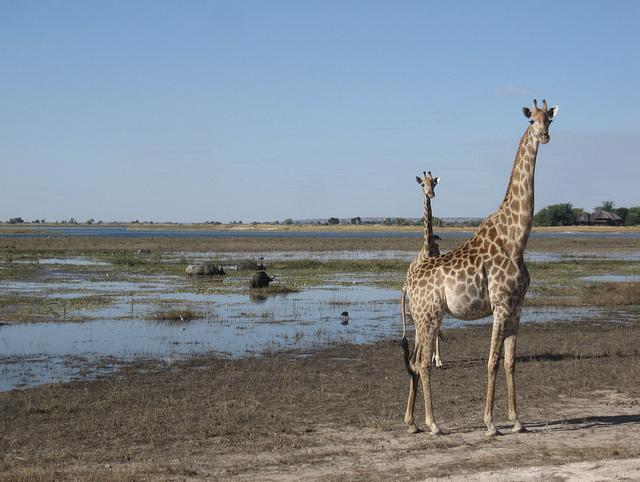The giraffe in the front is probably related to the one behind in what way? mother 